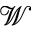<formula> <loc_0><loc_0><loc_500><loc_500>\mathcal { W }</formula> 